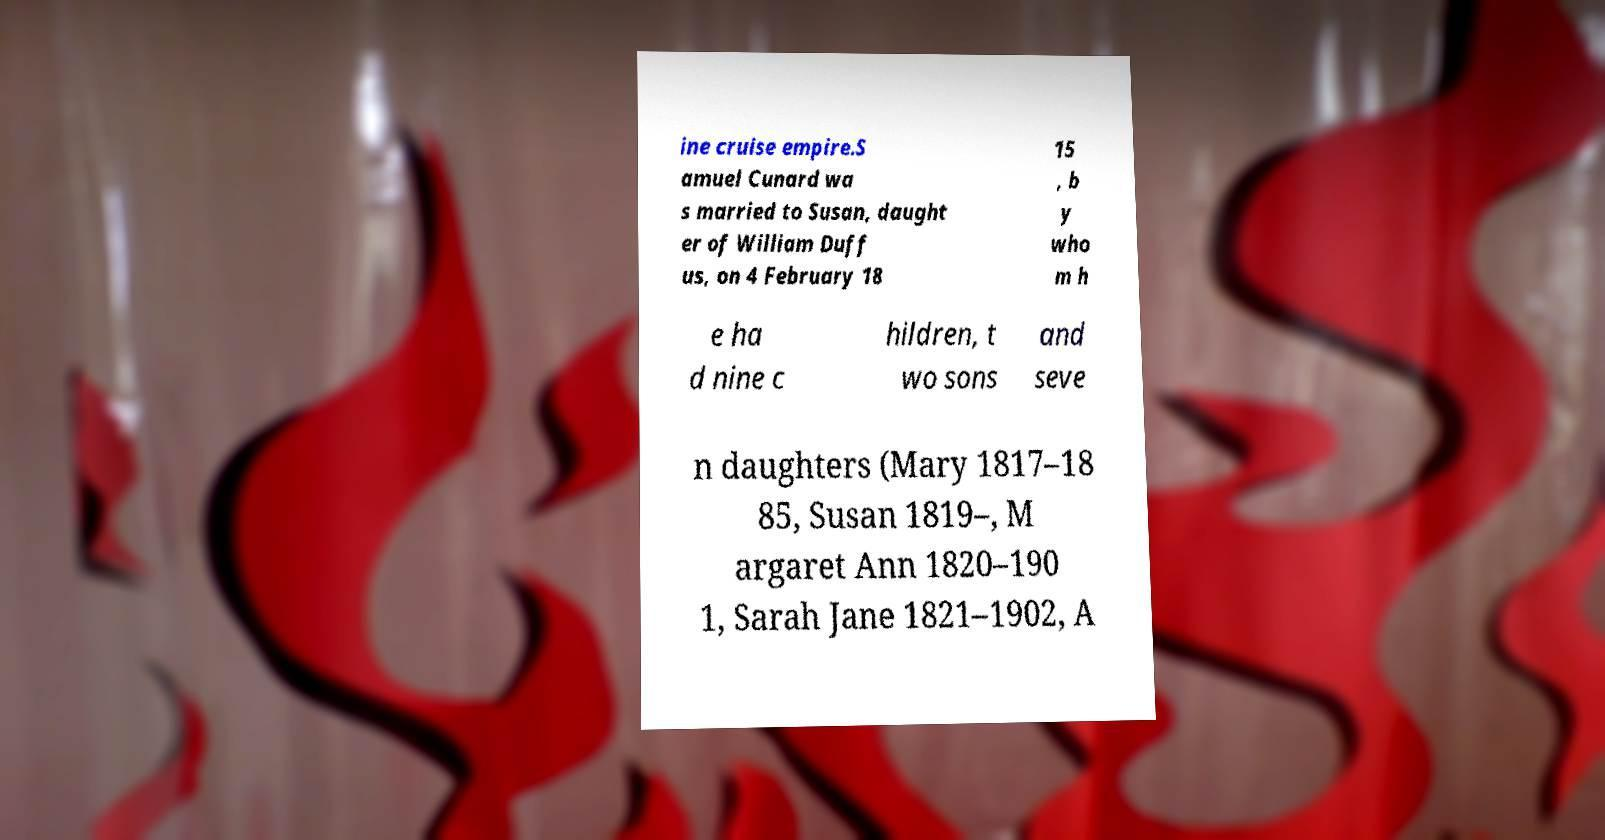What messages or text are displayed in this image? I need them in a readable, typed format. ine cruise empire.S amuel Cunard wa s married to Susan, daught er of William Duff us, on 4 February 18 15 , b y who m h e ha d nine c hildren, t wo sons and seve n daughters (Mary 1817–18 85, Susan 1819–, M argaret Ann 1820–190 1, Sarah Jane 1821–1902, A 